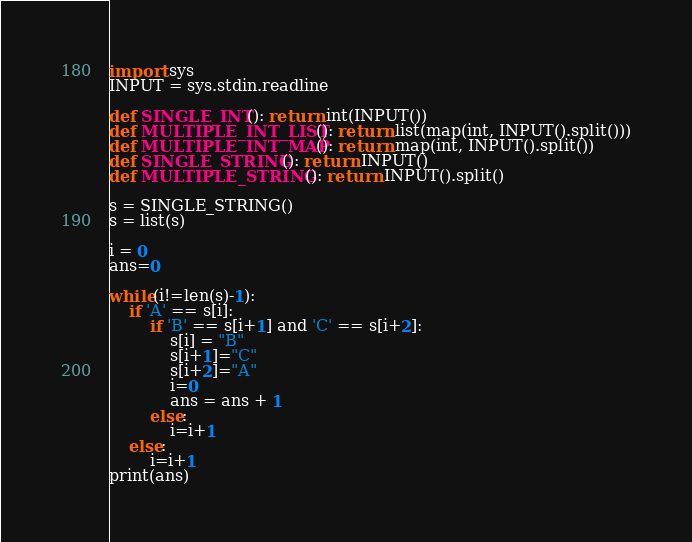<code> <loc_0><loc_0><loc_500><loc_500><_Python_>import sys
INPUT = sys.stdin.readline
 
def SINGLE_INT(): return int(INPUT())
def MULTIPLE_INT_LIST(): return list(map(int, INPUT().split()))
def MULTIPLE_INT_MAP(): return map(int, INPUT().split())
def SINGLE_STRING(): return INPUT()
def MULTIPLE_STRING(): return INPUT().split()

s = SINGLE_STRING()
s = list(s)

i = 0
ans=0

while(i!=len(s)-1):
    if 'A' == s[i]:
        if 'B' == s[i+1] and 'C' == s[i+2]:
            s[i] = "B"
            s[i+1]="C"
            s[i+2]="A"
            i=0
            ans = ans + 1
        else:
            i=i+1                
    else:
        i=i+1
print(ans)               </code> 